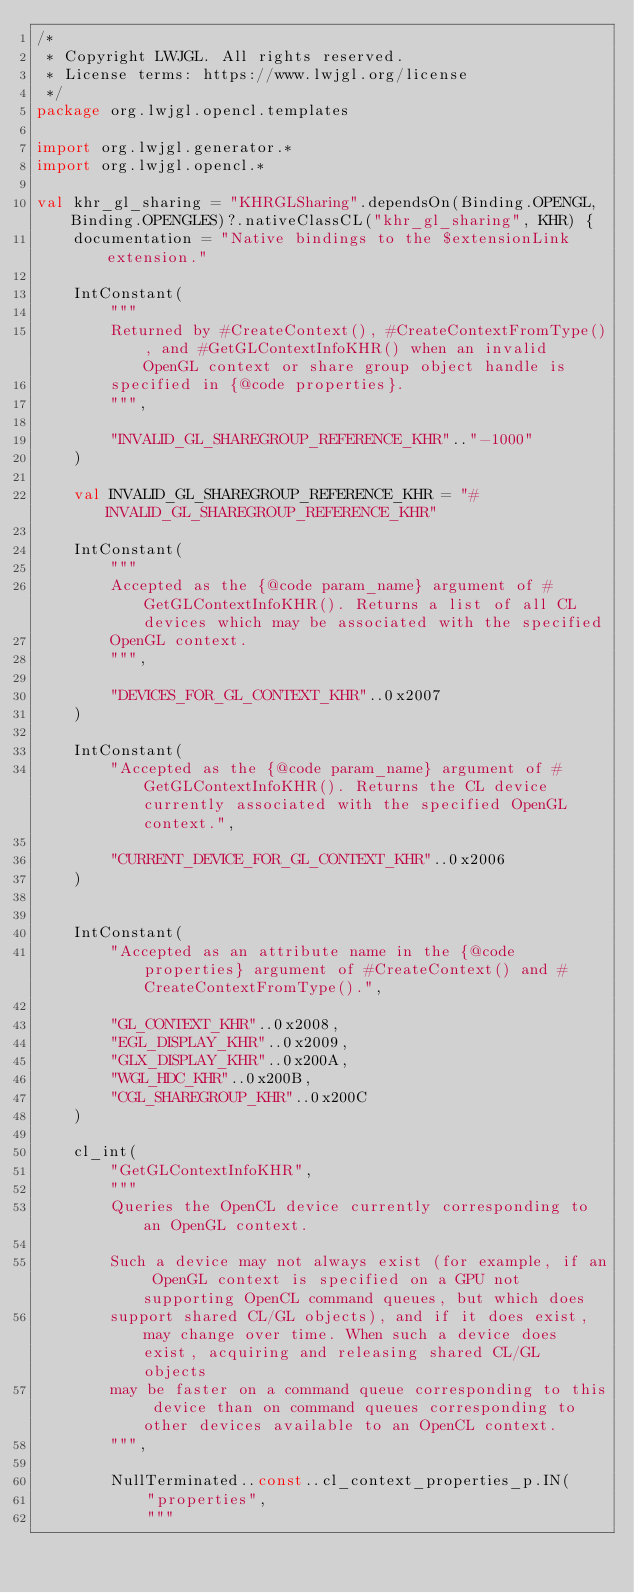<code> <loc_0><loc_0><loc_500><loc_500><_Kotlin_>/*
 * Copyright LWJGL. All rights reserved.
 * License terms: https://www.lwjgl.org/license
 */
package org.lwjgl.opencl.templates

import org.lwjgl.generator.*
import org.lwjgl.opencl.*

val khr_gl_sharing = "KHRGLSharing".dependsOn(Binding.OPENGL, Binding.OPENGLES)?.nativeClassCL("khr_gl_sharing", KHR) {
    documentation = "Native bindings to the $extensionLink extension."

    IntConstant(
        """
        Returned by #CreateContext(), #CreateContextFromType(), and #GetGLContextInfoKHR() when an invalid OpenGL context or share group object handle is
        specified in {@code properties}.
        """,

        "INVALID_GL_SHAREGROUP_REFERENCE_KHR".."-1000"
    )

    val INVALID_GL_SHAREGROUP_REFERENCE_KHR = "#INVALID_GL_SHAREGROUP_REFERENCE_KHR"

    IntConstant(
        """
        Accepted as the {@code param_name} argument of #GetGLContextInfoKHR(). Returns a list of all CL devices which may be associated with the specified
        OpenGL context.
        """,

        "DEVICES_FOR_GL_CONTEXT_KHR"..0x2007
    )

    IntConstant(
        "Accepted as the {@code param_name} argument of #GetGLContextInfoKHR(). Returns the CL device currently associated with the specified OpenGL context.",

        "CURRENT_DEVICE_FOR_GL_CONTEXT_KHR"..0x2006
    )


    IntConstant(
        "Accepted as an attribute name in the {@code properties} argument of #CreateContext() and #CreateContextFromType().",

        "GL_CONTEXT_KHR"..0x2008,
        "EGL_DISPLAY_KHR"..0x2009,
        "GLX_DISPLAY_KHR"..0x200A,
        "WGL_HDC_KHR"..0x200B,
        "CGL_SHAREGROUP_KHR"..0x200C
    )

    cl_int(
        "GetGLContextInfoKHR",
        """
        Queries the OpenCL device currently corresponding to an OpenGL context.

        Such a device may not always exist (for example, if an OpenGL context is specified on a GPU not supporting OpenCL command queues, but which does
        support shared CL/GL objects), and if it does exist, may change over time. When such a device does exist, acquiring and releasing shared CL/GL objects
        may be faster on a command queue corresponding to this device than on command queues corresponding to other devices available to an OpenCL context.
        """,

        NullTerminated..const..cl_context_properties_p.IN(
            "properties",
            """</code> 